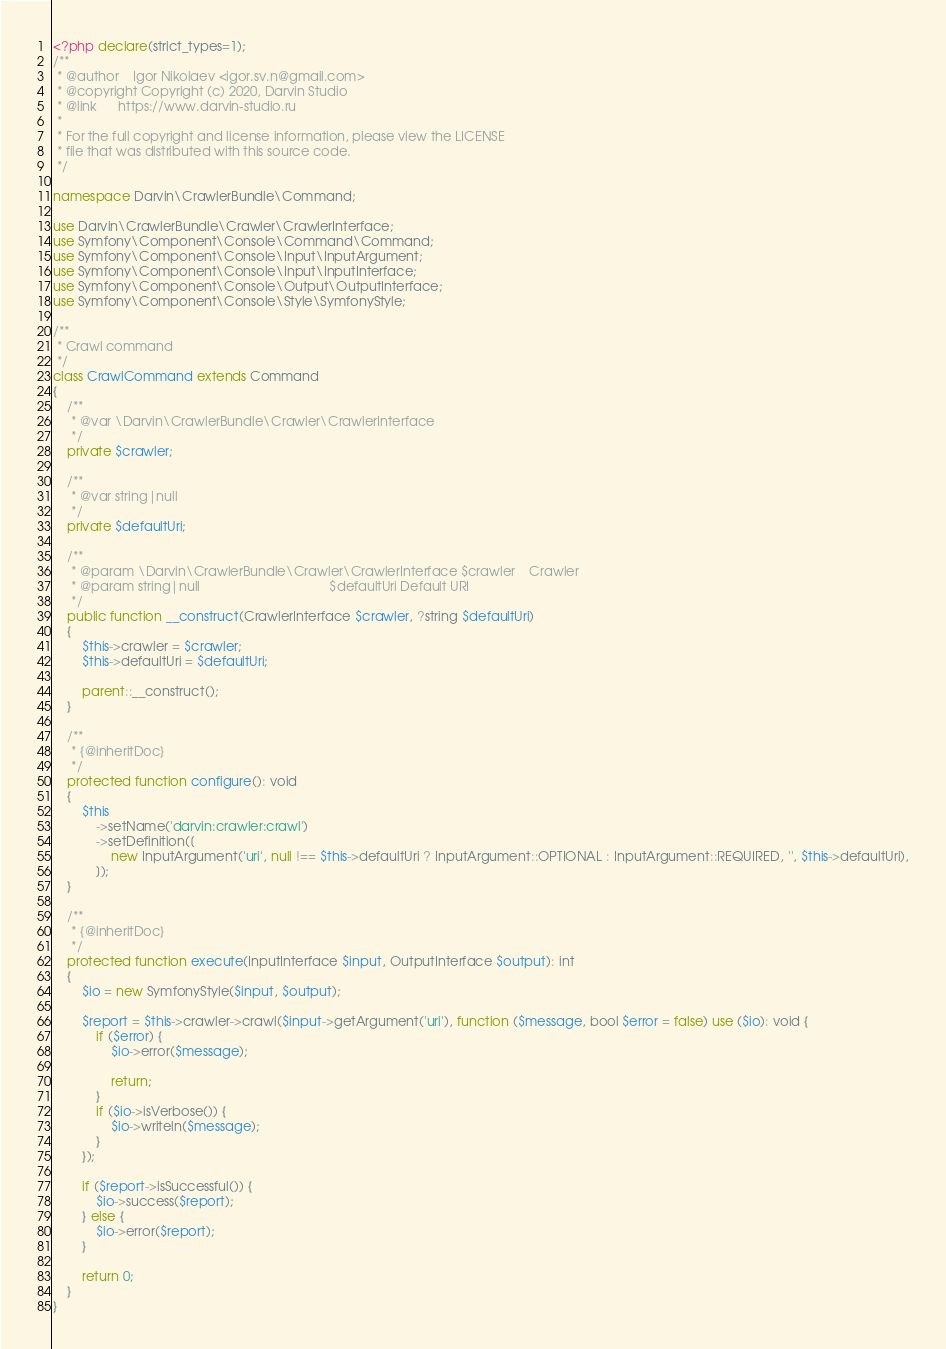Convert code to text. <code><loc_0><loc_0><loc_500><loc_500><_PHP_><?php declare(strict_types=1);
/**
 * @author    Igor Nikolaev <igor.sv.n@gmail.com>
 * @copyright Copyright (c) 2020, Darvin Studio
 * @link      https://www.darvin-studio.ru
 *
 * For the full copyright and license information, please view the LICENSE
 * file that was distributed with this source code.
 */

namespace Darvin\CrawlerBundle\Command;

use Darvin\CrawlerBundle\Crawler\CrawlerInterface;
use Symfony\Component\Console\Command\Command;
use Symfony\Component\Console\Input\InputArgument;
use Symfony\Component\Console\Input\InputInterface;
use Symfony\Component\Console\Output\OutputInterface;
use Symfony\Component\Console\Style\SymfonyStyle;

/**
 * Crawl command
 */
class CrawlCommand extends Command
{
    /**
     * @var \Darvin\CrawlerBundle\Crawler\CrawlerInterface
     */
    private $crawler;

    /**
     * @var string|null
     */
    private $defaultUri;

    /**
     * @param \Darvin\CrawlerBundle\Crawler\CrawlerInterface $crawler    Crawler
     * @param string|null                                    $defaultUri Default URI
     */
    public function __construct(CrawlerInterface $crawler, ?string $defaultUri)
    {
        $this->crawler = $crawler;
        $this->defaultUri = $defaultUri;

        parent::__construct();
    }

    /**
     * {@inheritDoc}
     */
    protected function configure(): void
    {
        $this
            ->setName('darvin:crawler:crawl')
            ->setDefinition([
                new InputArgument('uri', null !== $this->defaultUri ? InputArgument::OPTIONAL : InputArgument::REQUIRED, '', $this->defaultUri),
            ]);
    }

    /**
     * {@inheritDoc}
     */
    protected function execute(InputInterface $input, OutputInterface $output): int
    {
        $io = new SymfonyStyle($input, $output);

        $report = $this->crawler->crawl($input->getArgument('uri'), function ($message, bool $error = false) use ($io): void {
            if ($error) {
                $io->error($message);

                return;
            }
            if ($io->isVerbose()) {
                $io->writeln($message);
            }
        });

        if ($report->isSuccessful()) {
            $io->success($report);
        } else {
            $io->error($report);
        }

        return 0;
    }
}
</code> 